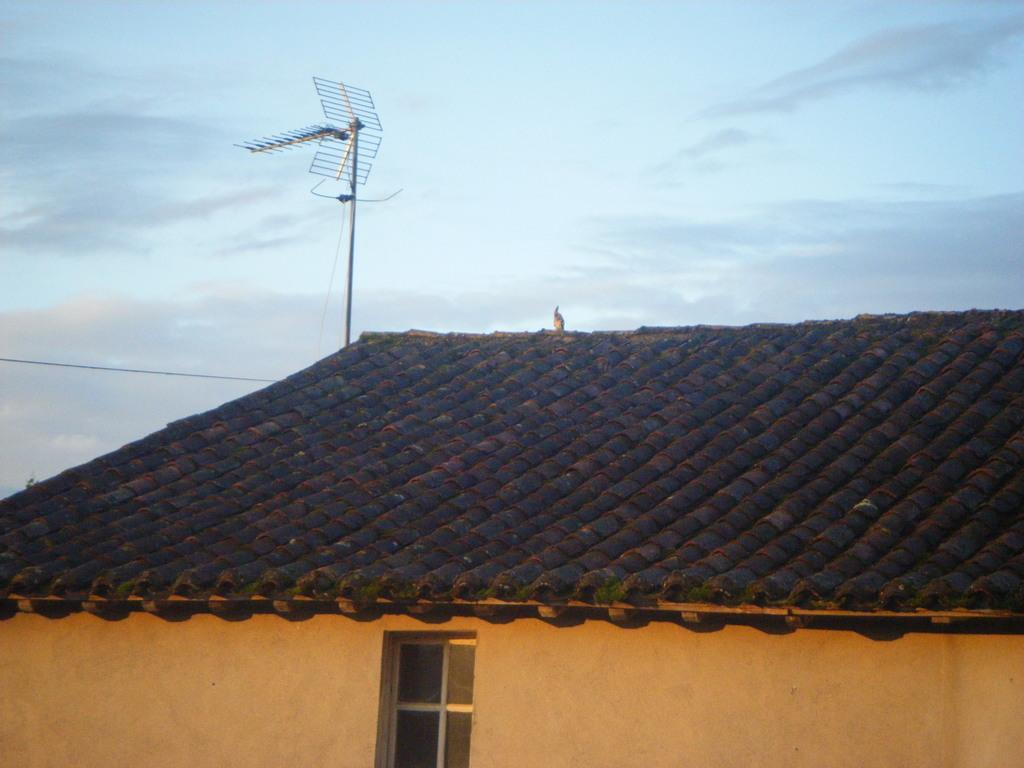What is one of the main structures in the image? There is a pole in the image. What else can be seen in the image? There is a wire, a roof, a wall, and a window in the image. What is visible in the background of the image? There are clouds in the sky in the background of the image. What type of account is being discussed in the image? There is no account being discussed in the image; it features a pole, wire, roof, wall, window, and clouds in the sky. What type of organization is depicted in the image? There is no organization depicted in the image; it features a pole, wire, roof, wall, window, and clouds in the sky. 